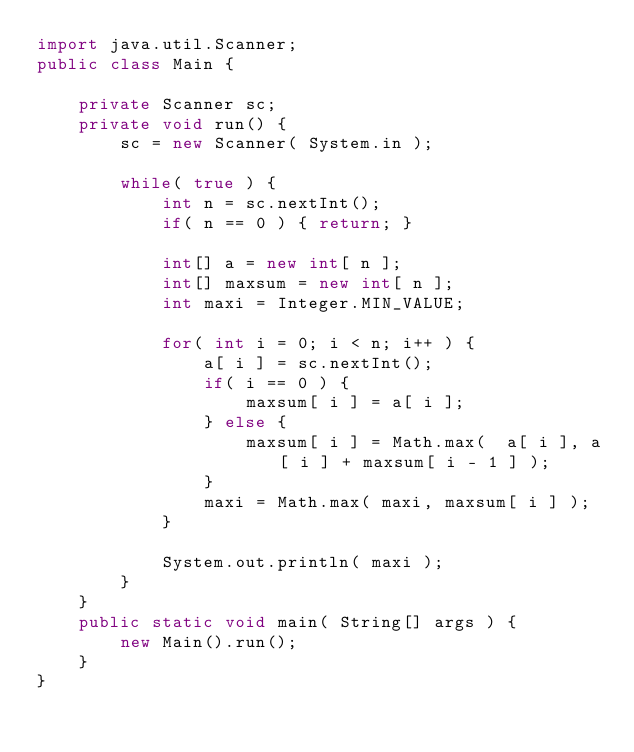<code> <loc_0><loc_0><loc_500><loc_500><_Java_>import java.util.Scanner;
public class Main {
	
	private Scanner sc;
	private void run() {
		sc = new Scanner( System.in );
		
		while( true ) {
			int n = sc.nextInt();
			if( n == 0 ) { return; }
			
			int[] a = new int[ n ];
			int[] maxsum = new int[ n ];
			int maxi = Integer.MIN_VALUE;
			
			for( int i = 0; i < n; i++ ) {
				a[ i ] = sc.nextInt();
				if( i == 0 ) {
					maxsum[ i ] = a[ i ];
				} else {
					maxsum[ i ] = Math.max(  a[ i ], a[ i ] + maxsum[ i - 1 ] );
				}
				maxi = Math.max( maxi, maxsum[ i ] );
			}
			
			System.out.println( maxi );
		}
	}
	public static void main( String[] args ) {
		new Main().run();
	}
}</code> 